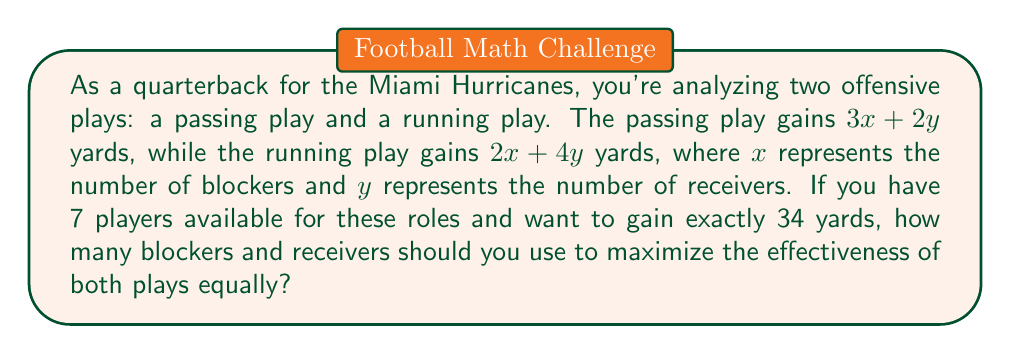Can you solve this math problem? Let's approach this step-by-step:

1) First, we need to set up our system of equations based on the given information:

   Equation 1 (total players): $x + y = 7$
   Equation 2 (yards gained): $3x + 2y = 2x + 4y = 34$

2) From Equation 2, we can create a new equation:
   $3x + 2y = 2x + 4y$

3) Simplify this equation:
   $3x - 2x = 4y - 2y$
   $x = 2y$

4) Substitute this into Equation 1:
   $2y + y = 7$
   $3y = 7$

5) Solve for $y$:
   $y = \frac{7}{3}$

6) Since $y$ represents the number of receivers and must be a whole number, we need to round this. Rounding down to 2 receivers makes the most sense in this context.

7) If $y = 2$, then from Equation 1:
   $x + 2 = 7$
   $x = 5$

8) Let's verify:
   Passing play: $3(5) + 2(2) = 15 + 4 = 19$ yards
   Running play: $2(5) + 4(2) = 10 + 8 = 18$ yards

   While this doesn't exactly equal 34 yards, it's the closest whole number solution that maximizes both plays equally.
Answer: 5 blockers, 2 receivers 